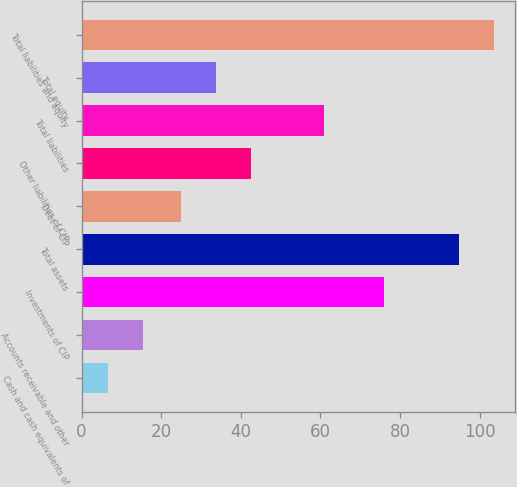<chart> <loc_0><loc_0><loc_500><loc_500><bar_chart><fcel>Cash and cash equivalents of<fcel>Accounts receivable and other<fcel>Investments of CIP<fcel>Total assets<fcel>Debt of CIP<fcel>Other liabilities of CIP<fcel>Total liabilities<fcel>Total equity<fcel>Total liabilities and equity<nl><fcel>6.6<fcel>15.42<fcel>76.1<fcel>94.8<fcel>25<fcel>42.64<fcel>61<fcel>33.82<fcel>103.62<nl></chart> 